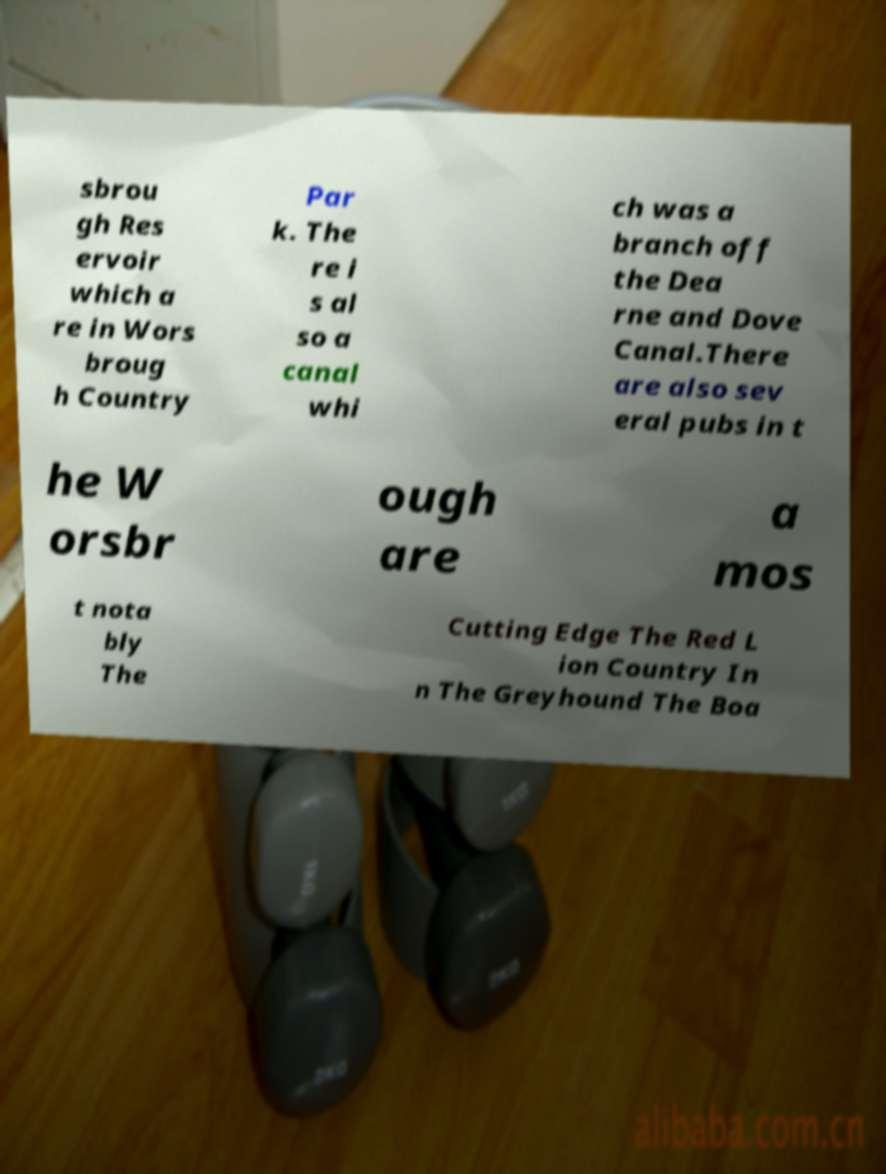I need the written content from this picture converted into text. Can you do that? sbrou gh Res ervoir which a re in Wors broug h Country Par k. The re i s al so a canal whi ch was a branch off the Dea rne and Dove Canal.There are also sev eral pubs in t he W orsbr ough are a mos t nota bly The Cutting Edge The Red L ion Country In n The Greyhound The Boa 